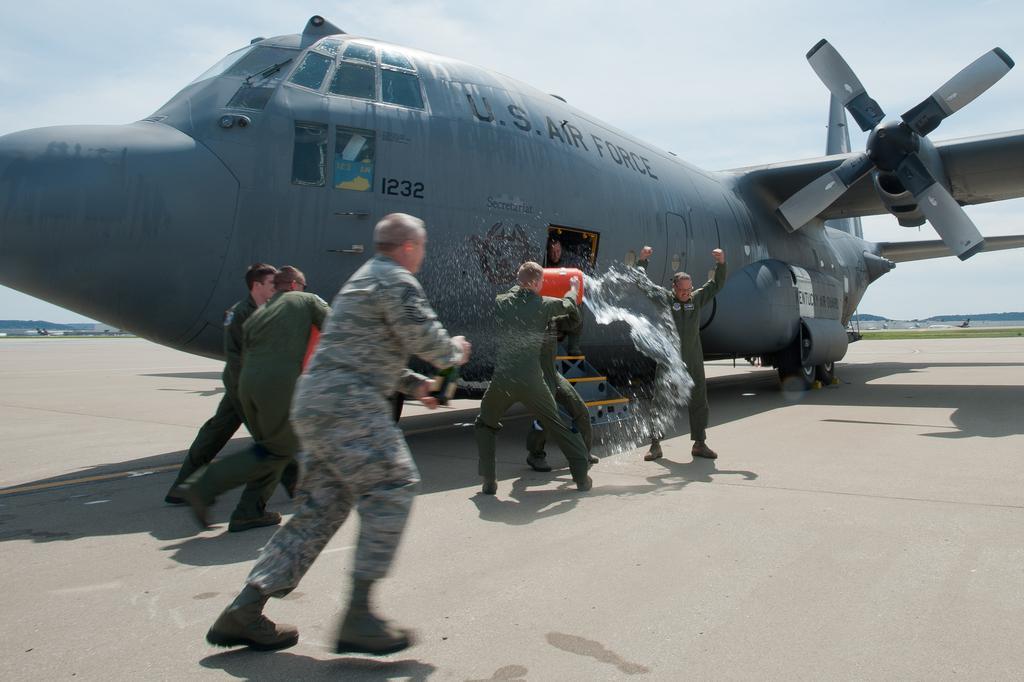Please provide a concise description of this image. In this image in the front there are group of persons playing with water. In the center there is an airplane with some text written on it. In the background there is grass on the ground and there are mountains, trees and the sky is cloudy. 